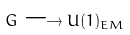Convert formula to latex. <formula><loc_0><loc_0><loc_500><loc_500>G \longrightarrow U ( 1 ) _ { E M }</formula> 